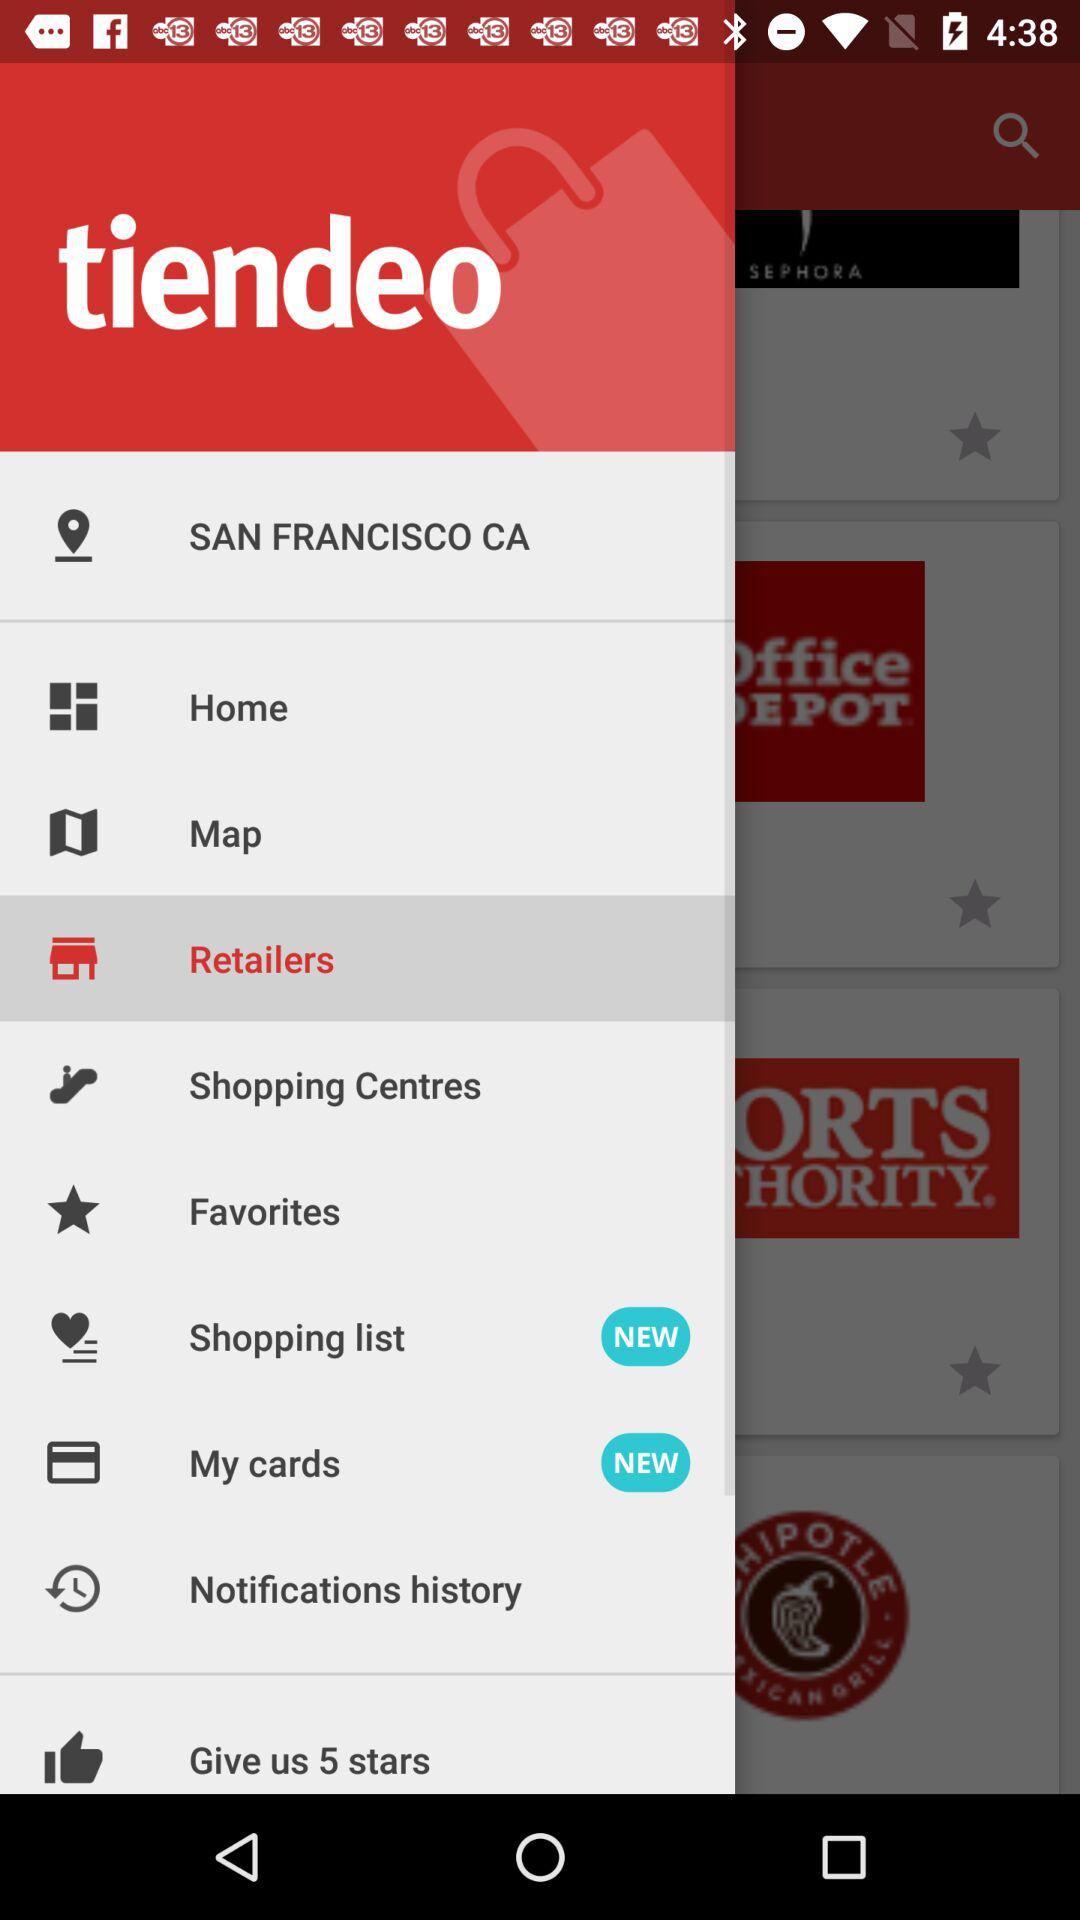How many notifications are there in "Favorites"?
When the provided information is insufficient, respond with <no answer>. <no answer> 